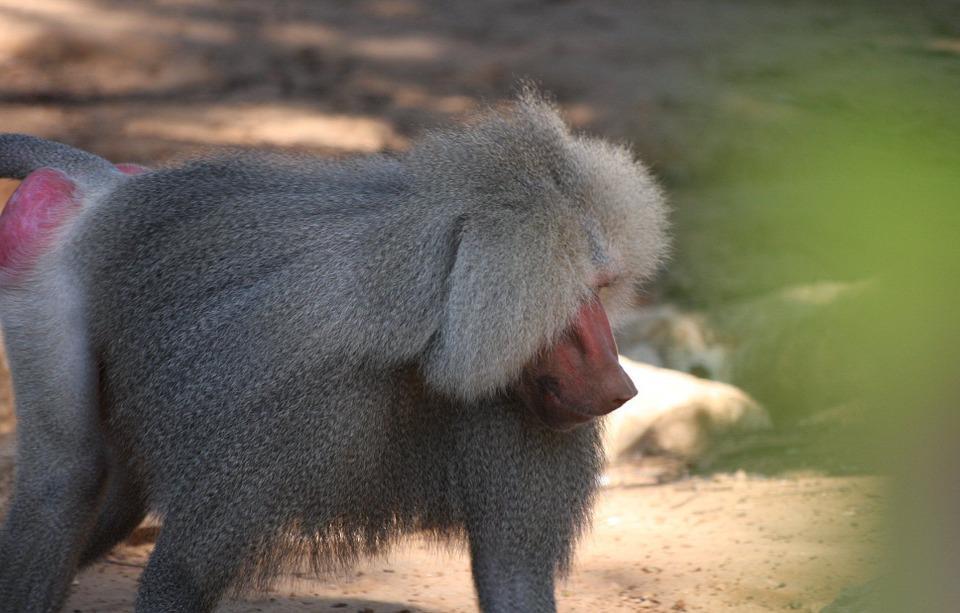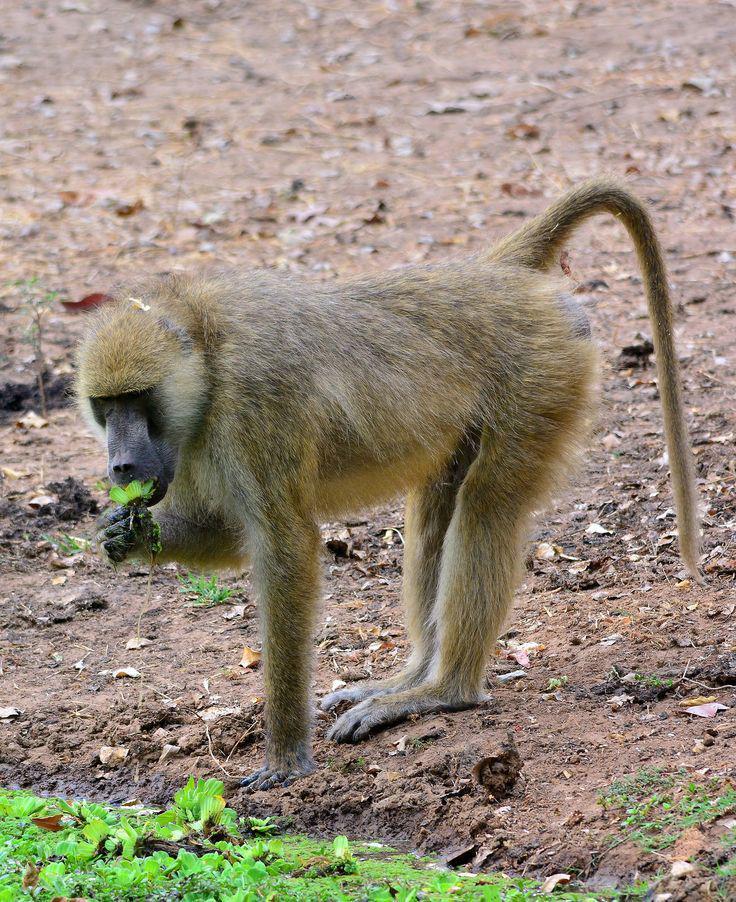The first image is the image on the left, the second image is the image on the right. For the images displayed, is the sentence "There is at least one male sacred baboon." factually correct? Answer yes or no. Yes. The first image is the image on the left, the second image is the image on the right. Considering the images on both sides, is "Each image contains a single baboon, and all baboons are in standing positions." valid? Answer yes or no. Yes. 